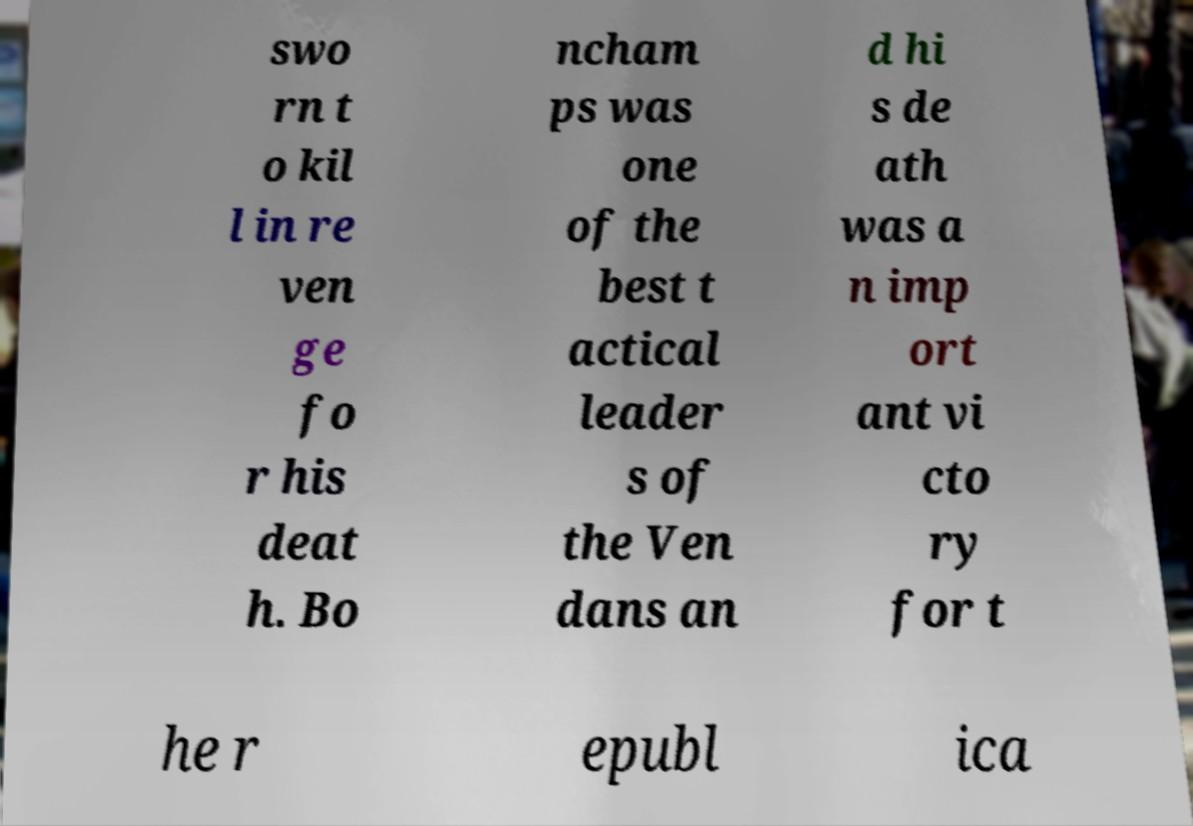Please read and relay the text visible in this image. What does it say? swo rn t o kil l in re ven ge fo r his deat h. Bo ncham ps was one of the best t actical leader s of the Ven dans an d hi s de ath was a n imp ort ant vi cto ry for t he r epubl ica 